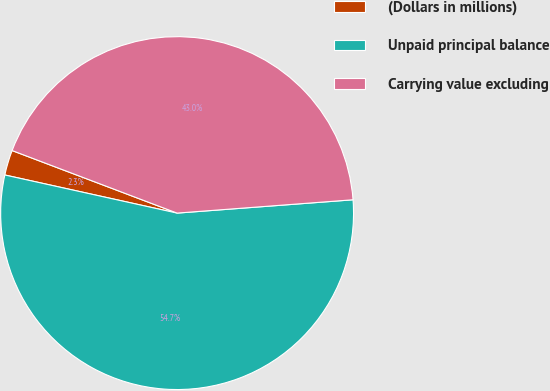Convert chart. <chart><loc_0><loc_0><loc_500><loc_500><pie_chart><fcel>(Dollars in millions)<fcel>Unpaid principal balance<fcel>Carrying value excluding<nl><fcel>2.3%<fcel>54.67%<fcel>43.03%<nl></chart> 